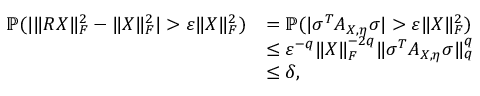Convert formula to latex. <formula><loc_0><loc_0><loc_500><loc_500>\begin{array} { r l } { \mathbb { P } ( | \| R X \| _ { F } ^ { 2 } - \| X \| _ { F } ^ { 2 } | > \varepsilon \| X \| _ { F } ^ { 2 } ) } & { = \mathbb { P } ( | \sigma ^ { T } A _ { X , \eta } \sigma | > \varepsilon \| X \| _ { F } ^ { 2 } ) } \\ & { \leq \varepsilon ^ { - q } \| X \| _ { F } ^ { - 2 q } \| \sigma ^ { T } A _ { X , \eta } \sigma \| _ { q } ^ { q } } \\ & { \leq \delta , } \end{array}</formula> 